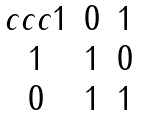<formula> <loc_0><loc_0><loc_500><loc_500>\begin{matrix} { c c c } 1 & 0 & 1 \\ 1 & 1 & 0 \\ 0 & 1 & 1 \end{matrix}</formula> 